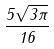<formula> <loc_0><loc_0><loc_500><loc_500>\frac { 5 \sqrt { 3 \pi } } { 1 6 }</formula> 